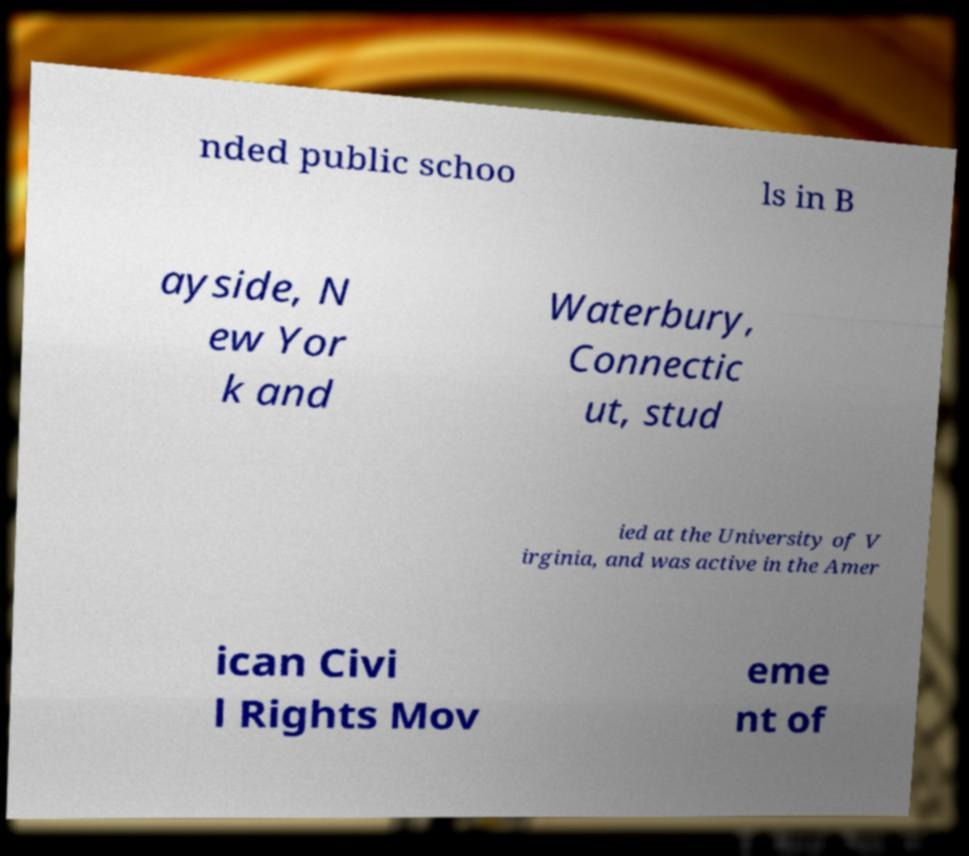What messages or text are displayed in this image? I need them in a readable, typed format. nded public schoo ls in B ayside, N ew Yor k and Waterbury, Connectic ut, stud ied at the University of V irginia, and was active in the Amer ican Civi l Rights Mov eme nt of 